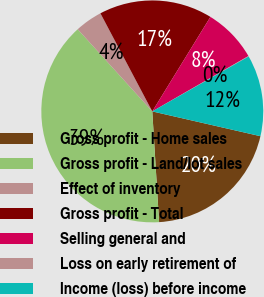Convert chart to OTSL. <chart><loc_0><loc_0><loc_500><loc_500><pie_chart><fcel>Gross profit - Home sales<fcel>Gross profit - Land/lot sales<fcel>Effect of inventory<fcel>Gross profit - Total<fcel>Selling general and<fcel>Loss on early retirement of<fcel>Income (loss) before income<nl><fcel>20.44%<fcel>39.25%<fcel>3.99%<fcel>16.52%<fcel>7.91%<fcel>0.07%<fcel>11.83%<nl></chart> 